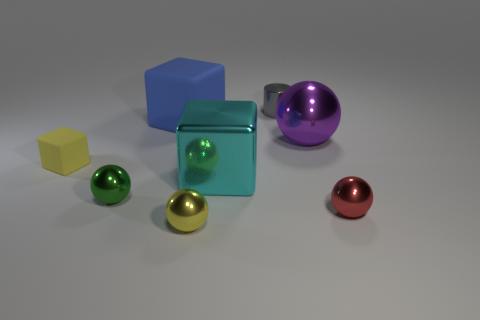Subtract all tiny balls. How many balls are left? 1 Subtract all red spheres. How many spheres are left? 3 Subtract 1 balls. How many balls are left? 3 Add 2 red metal balls. How many objects exist? 10 Subtract all cubes. How many objects are left? 5 Add 4 big cubes. How many big cubes are left? 6 Add 5 small red blocks. How many small red blocks exist? 5 Subtract 0 green blocks. How many objects are left? 8 Subtract all yellow balls. Subtract all cyan cylinders. How many balls are left? 3 Subtract all large brown matte balls. Subtract all tiny cylinders. How many objects are left? 7 